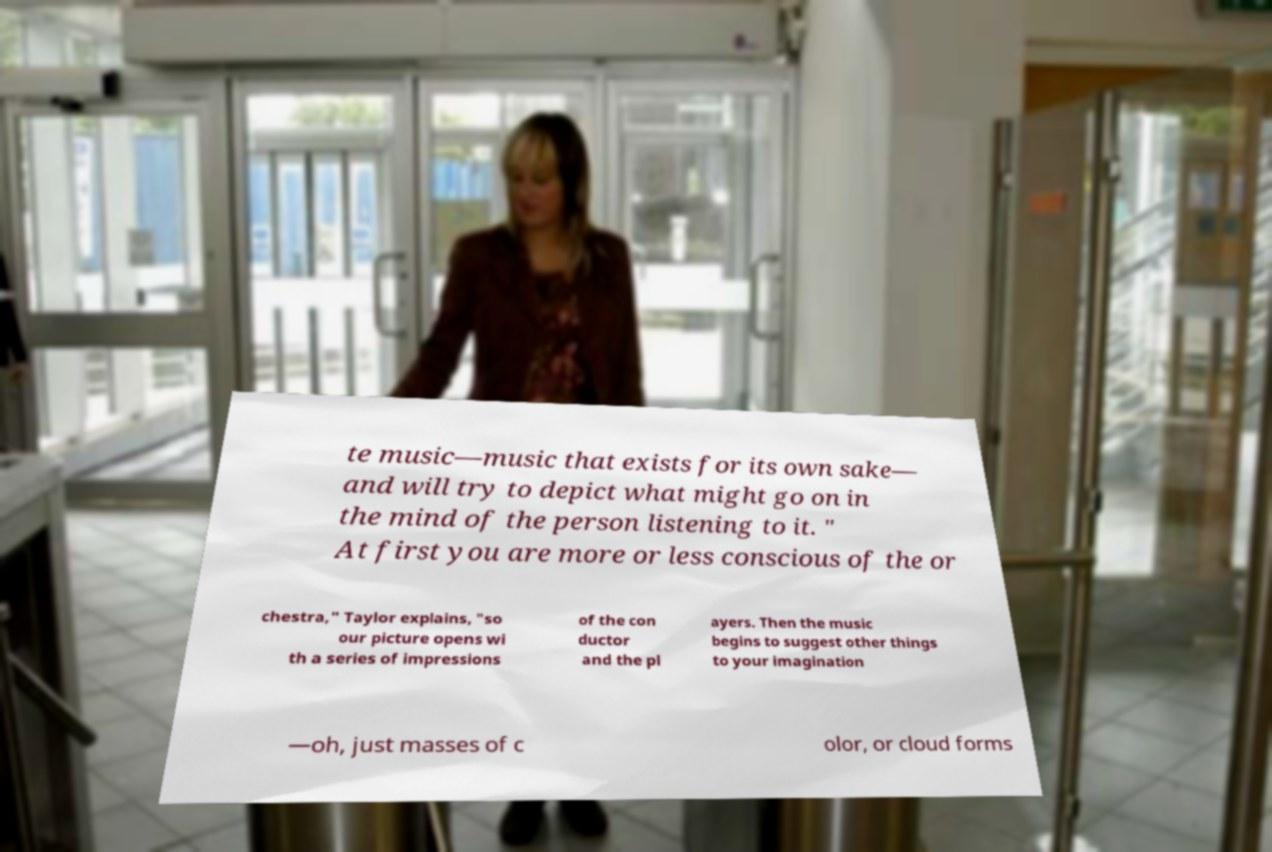Please identify and transcribe the text found in this image. te music—music that exists for its own sake— and will try to depict what might go on in the mind of the person listening to it. " At first you are more or less conscious of the or chestra," Taylor explains, "so our picture opens wi th a series of impressions of the con ductor and the pl ayers. Then the music begins to suggest other things to your imagination —oh, just masses of c olor, or cloud forms 